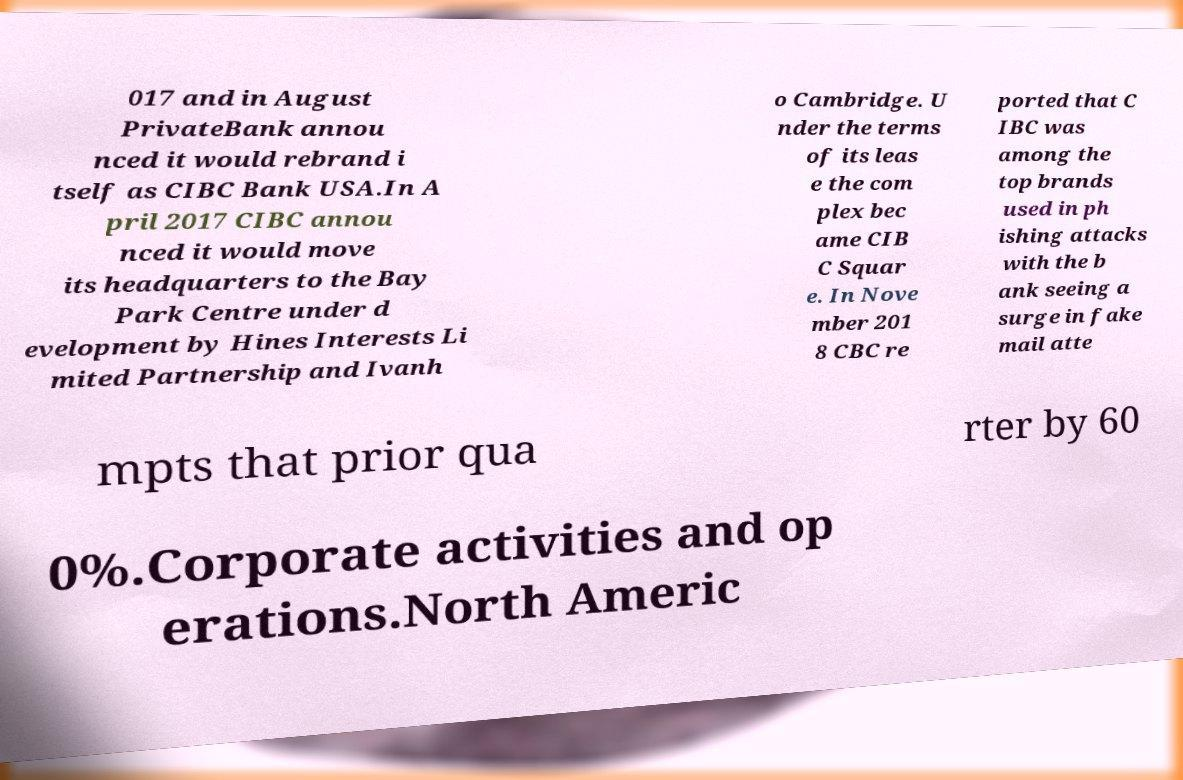There's text embedded in this image that I need extracted. Can you transcribe it verbatim? 017 and in August PrivateBank annou nced it would rebrand i tself as CIBC Bank USA.In A pril 2017 CIBC annou nced it would move its headquarters to the Bay Park Centre under d evelopment by Hines Interests Li mited Partnership and Ivanh o Cambridge. U nder the terms of its leas e the com plex bec ame CIB C Squar e. In Nove mber 201 8 CBC re ported that C IBC was among the top brands used in ph ishing attacks with the b ank seeing a surge in fake mail atte mpts that prior qua rter by 60 0%.Corporate activities and op erations.North Americ 